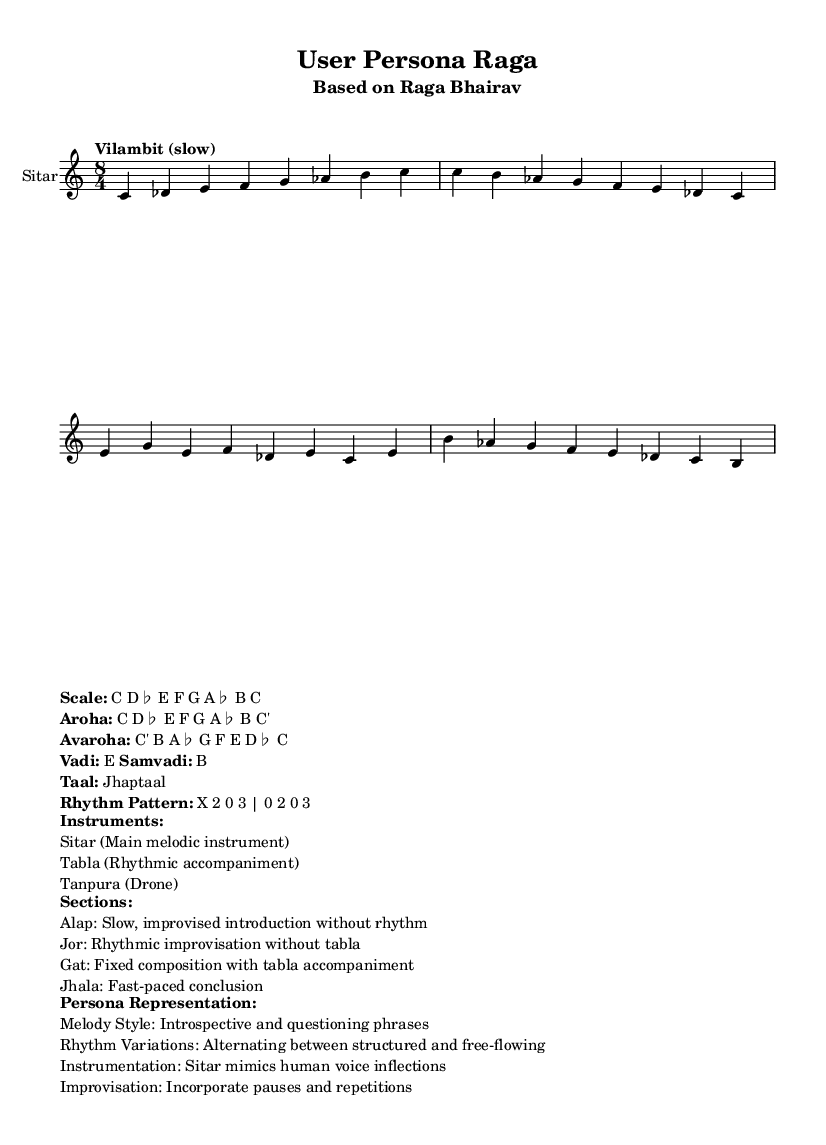What is the key signature of this music? The key signature is indicated as C major, which shows no sharps or flats in the key signature area.
Answer: C major What is the time signature of the piece? The time signature displayed is 8/4, which indicates there are 8 beats in each measure and the quarter note receives one beat.
Answer: 8/4 What is the tempo marking for the raga? The tempo marking states "Vilambit (slow)", indicating that the piece is to be played slowly.
Answer: Vilambit (slow) What is the vadi of this raga? The vadi is indicated as E, which is the most prominent note in the raga's structure.
Answer: E How many sections are described in the piece? The score describes four sections: Alap, Jor, Gat, and Jhala; each plays a distinct role in the overall structure of the performance.
Answer: Four What is the primary melodic instrument used in this piece? The instrument listed as the main melodic instrument in the score is the Sitar, which is a central element in this performance.
Answer: Sitar 